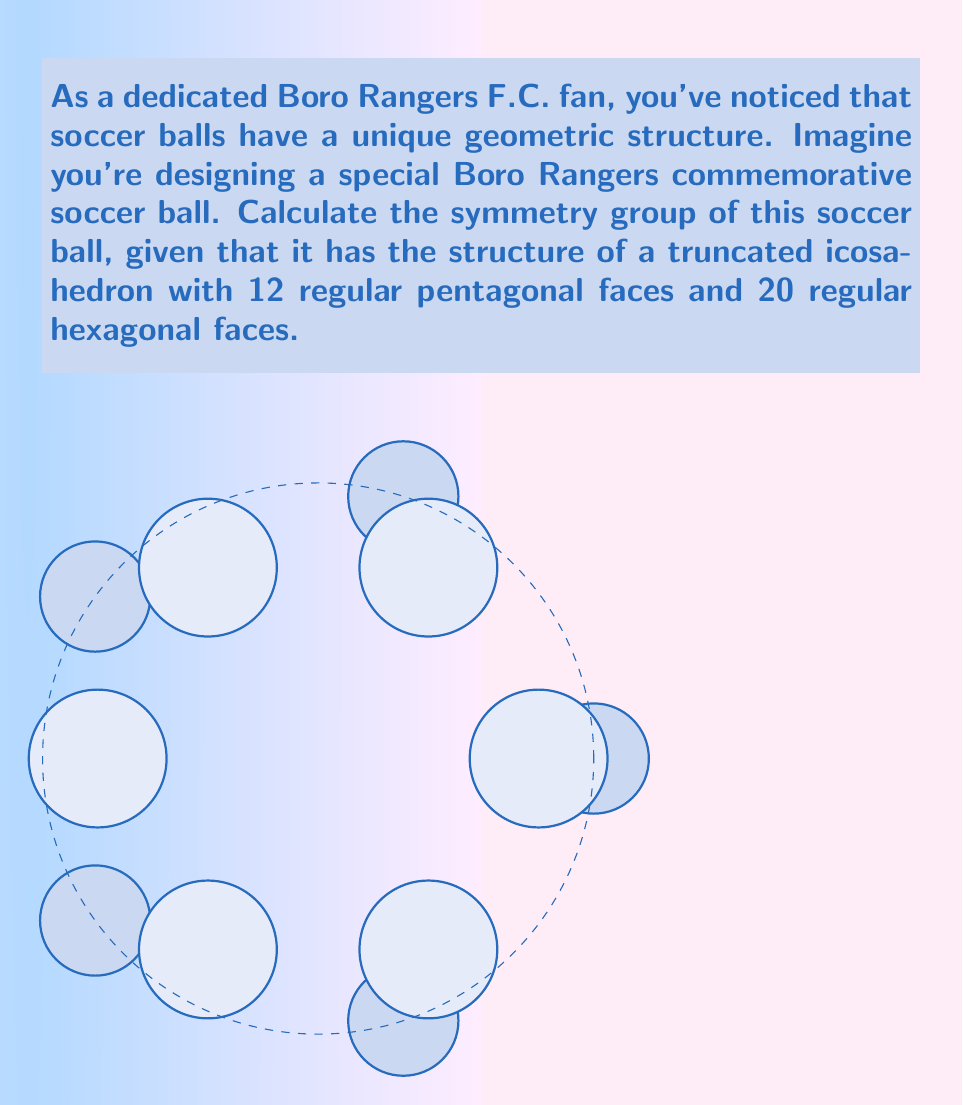Show me your answer to this math problem. To calculate the symmetry group of a soccer ball, we need to consider its structure as a truncated icosahedron. Let's break this down step-by-step:

1) A truncated icosahedron has the same symmetry group as a regular icosahedron, which is the icosahedral group.

2) The icosahedral group, denoted as $I_h$, is a point group in three dimensions.

3) To determine the order of $I_h$, we need to count its symmetry operations:
   - 12 five-fold rotation axes (through the centers of the pentagonal faces)
   - 20 three-fold rotation axes (through the centers of the hexagonal faces)
   - 15 two-fold rotation axes (through the midpoints of the edges)
   - A center of inversion
   - 15 mirror planes (through opposite edges)

4) The total number of symmetry operations is:
   $$(12 \cdot 4) + (20 \cdot 2) + (15 \cdot 1) + 1 + 15 = 48 + 40 + 15 + 1 + 15 = 119$$

5) Including the identity element, the total order of the group is 120.

6) The structure of $I_h$ can be described as:
   $$I_h \cong A_5 \times \mathbb{Z}_2$$
   where $A_5$ is the alternating group on 5 elements (order 60), and $\mathbb{Z}_2$ is the cyclic group of order 2.

Therefore, the symmetry group of a soccer ball is the icosahedral group $I_h$ of order 120.
Answer: $I_h$, order 120 